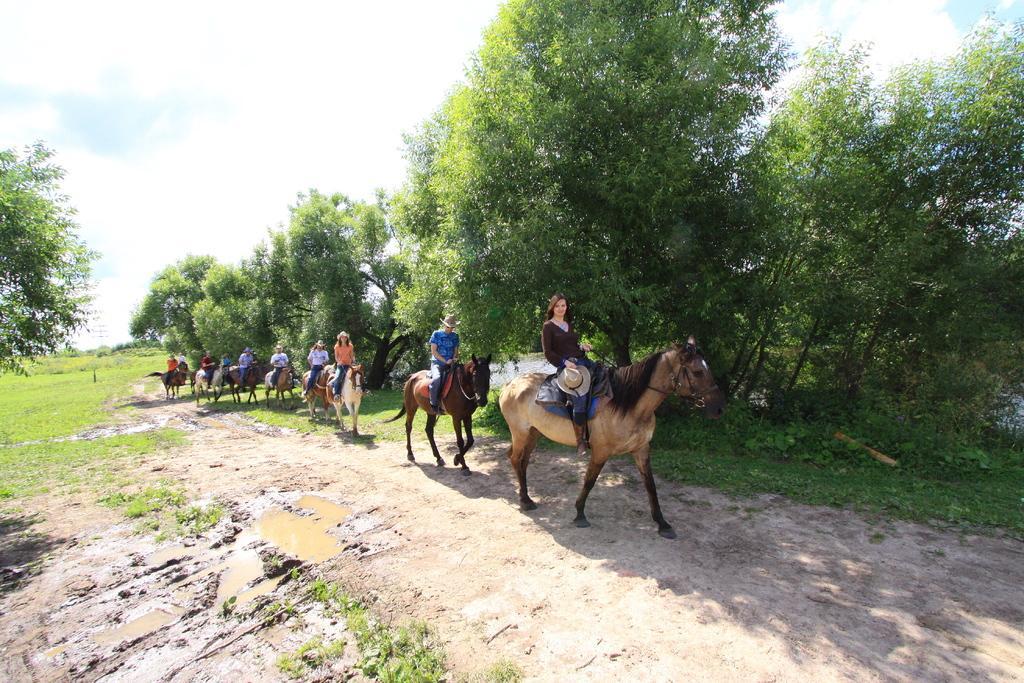Please provide a concise description of this image. In this image we can see people sitting on horses and riding. On the ground there is mud with water. Also there's grass on the ground. And there are trees. In the background there is sky with clouds. 